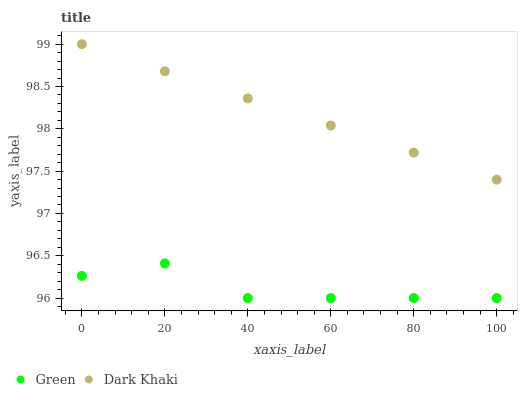Does Green have the minimum area under the curve?
Answer yes or no. Yes. Does Dark Khaki have the maximum area under the curve?
Answer yes or no. Yes. Does Green have the maximum area under the curve?
Answer yes or no. No. Is Dark Khaki the smoothest?
Answer yes or no. Yes. Is Green the roughest?
Answer yes or no. Yes. Is Green the smoothest?
Answer yes or no. No. Does Green have the lowest value?
Answer yes or no. Yes. Does Dark Khaki have the highest value?
Answer yes or no. Yes. Does Green have the highest value?
Answer yes or no. No. Is Green less than Dark Khaki?
Answer yes or no. Yes. Is Dark Khaki greater than Green?
Answer yes or no. Yes. Does Green intersect Dark Khaki?
Answer yes or no. No. 